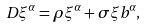<formula> <loc_0><loc_0><loc_500><loc_500>D \xi ^ { \alpha } = \rho \xi ^ { \alpha } + \sigma \xi b ^ { \alpha } ,</formula> 